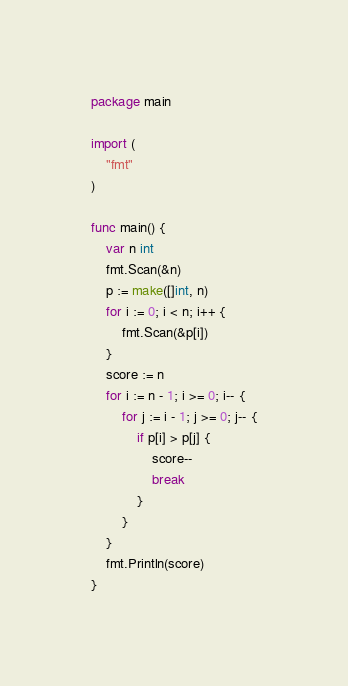Convert code to text. <code><loc_0><loc_0><loc_500><loc_500><_Go_>package main

import (
	"fmt"
)

func main() {
	var n int
	fmt.Scan(&n)
	p := make([]int, n)
	for i := 0; i < n; i++ {
		fmt.Scan(&p[i])
	}
	score := n
	for i := n - 1; i >= 0; i-- {
		for j := i - 1; j >= 0; j-- {
			if p[i] > p[j] {
				score--
				break
			}
		}
	}
	fmt.Println(score)
}
</code> 